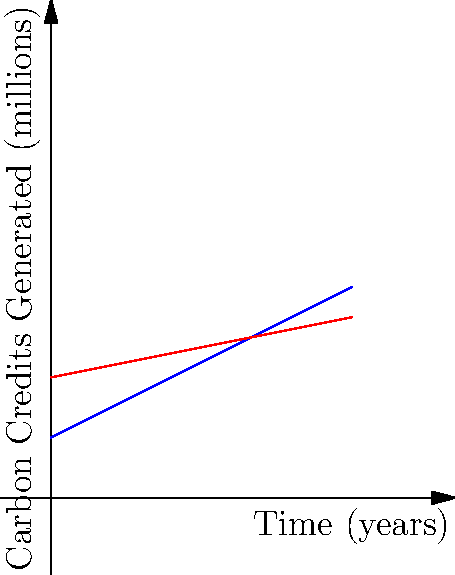The graph shows the rate of carbon credit generation for two different projects over time. Which project is generating carbon credits at a faster rate, and what does this imply about the project's effectiveness in reducing greenhouse gas emissions? To determine which project is generating carbon credits at a faster rate, we need to analyze the slope of each line:

1. The slope of a line represents the rate of change. In this context, it shows how quickly carbon credits are being generated over time.

2. Project A (blue line):
   - Has a steeper slope
   - The line rises more quickly as time increases

3. Project B (red line):
   - Has a gentler slope
   - The line rises more slowly as time increases

4. A steeper slope indicates a faster rate of carbon credit generation.

5. Therefore, Project A is generating carbon credits at a faster rate than Project B.

6. Implications:
   - Faster carbon credit generation suggests that Project A is more effective at reducing greenhouse gas emissions in a shorter time frame.
   - Project A may be implementing more efficient or innovative technologies or practices to achieve quicker results.
   - However, it's important to note that the total number of credits generated over time (area under the curve) should also be considered for a comprehensive comparison.
Answer: Project A; it's more effective at rapidly reducing emissions. 